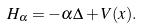<formula> <loc_0><loc_0><loc_500><loc_500>H _ { \alpha } = - \alpha \Delta + V ( { x } ) .</formula> 